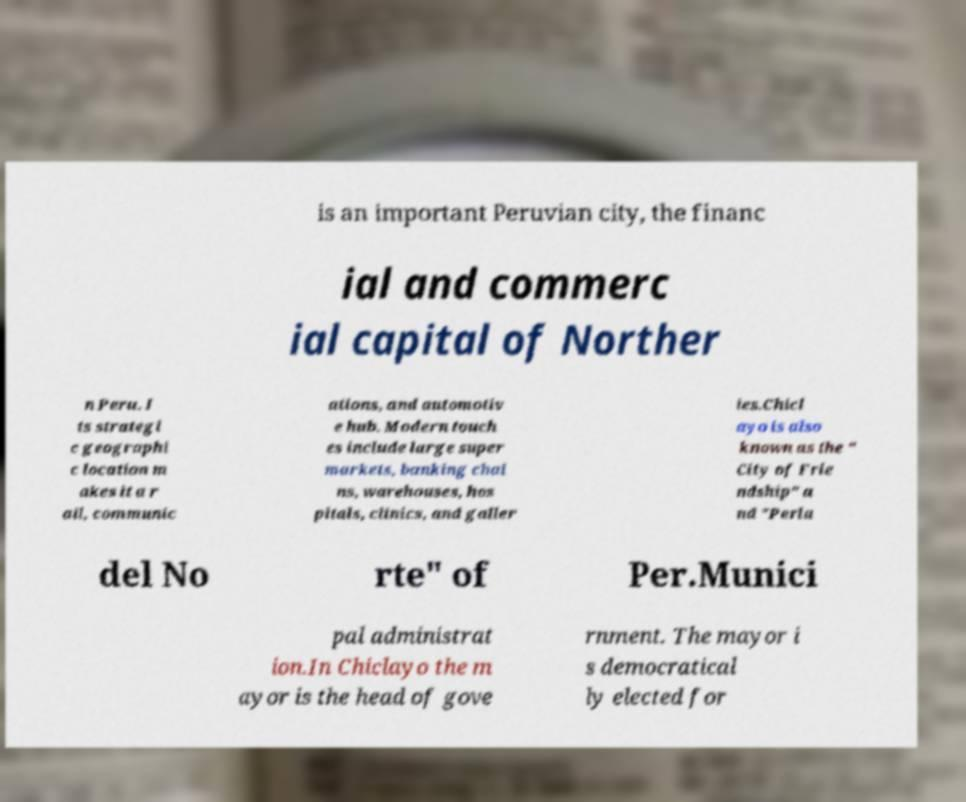Can you read and provide the text displayed in the image?This photo seems to have some interesting text. Can you extract and type it out for me? is an important Peruvian city, the financ ial and commerc ial capital of Norther n Peru. I ts strategi c geographi c location m akes it a r ail, communic ations, and automotiv e hub. Modern touch es include large super markets, banking chai ns, warehouses, hos pitals, clinics, and galler ies.Chicl ayo is also known as the " City of Frie ndship" a nd "Perla del No rte" of Per.Munici pal administrat ion.In Chiclayo the m ayor is the head of gove rnment. The mayor i s democratical ly elected for 